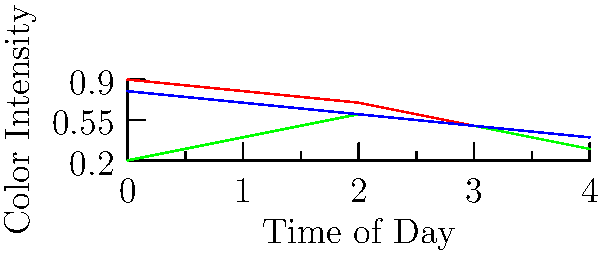In creating a color palette for different biomes in a game world, you notice that the color intensity of each biome changes throughout the day. Based on the graph, which biome shows the most significant change in color intensity from dawn to dusk, and how might this affect your approach to designing the game's lighting system? To determine which biome shows the most significant change in color intensity, we need to analyze the graph for each biome:

1. Desert (red line):
   - Starts at 0.9 and ends at 0.3
   - Total change: 0.9 - 0.3 = 0.6

2. Forest (green line):
   - Starts at 0.2 and ends at 0.3
   - Total change: 0.3 - 0.2 = 0.1

3. Tundra (blue line):
   - Starts at 0.8 and ends at 0.4
   - Total change: 0.8 - 0.4 = 0.4

The desert biome shows the most significant change in color intensity, with a total change of 0.6.

This observation affects the lighting system design in several ways:

1. Dynamic Lighting: The desert will require a more dynamic lighting system to accurately represent the dramatic shift in color intensity throughout the day.

2. Shader Complexity: More complex shaders may be needed for the desert to handle the wider range of color intensities.

3. Time-based Effects: Special effects like heat haze or mirages in the desert might need to be adjusted based on the time of day to match the changing color intensity.

4. Contrast with Other Biomes: The stark difference in color intensity changes between the desert and other biomes can be used to create visual variety and distinctiveness in the game world.

5. Performance Considerations: The more dramatic changes in the desert might require more frequent updates to the lighting system, which could impact performance and need to be optimized.
Answer: Desert; requires more dynamic lighting system, complex shaders, and time-based effects. 